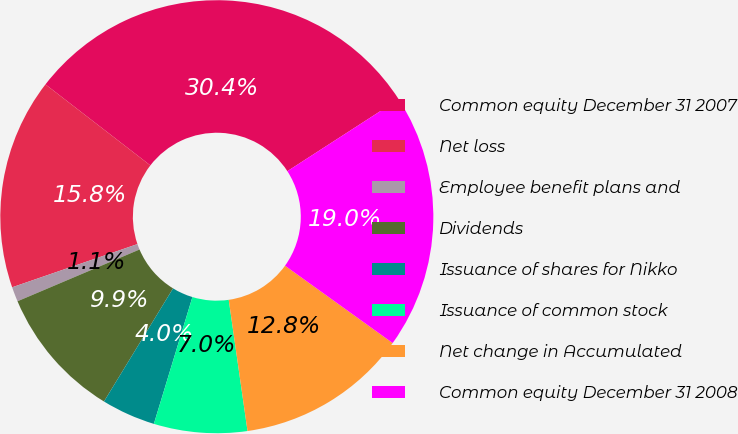<chart> <loc_0><loc_0><loc_500><loc_500><pie_chart><fcel>Common equity December 31 2007<fcel>Net loss<fcel>Employee benefit plans and<fcel>Dividends<fcel>Issuance of shares for Nikko<fcel>Issuance of common stock<fcel>Net change in Accumulated<fcel>Common equity December 31 2008<nl><fcel>30.41%<fcel>15.75%<fcel>1.1%<fcel>9.89%<fcel>4.03%<fcel>6.96%<fcel>12.82%<fcel>19.04%<nl></chart> 